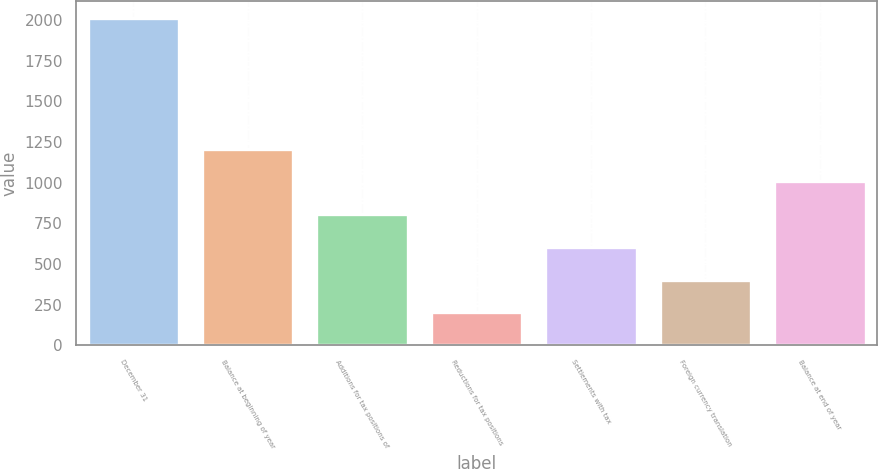Convert chart to OTSL. <chart><loc_0><loc_0><loc_500><loc_500><bar_chart><fcel>December 31<fcel>Balance at beginning of year<fcel>Additions for tax positions of<fcel>Reductions for tax positions<fcel>Settlements with tax<fcel>Foreign currency translation<fcel>Balance at end of year<nl><fcel>2013<fcel>1208.6<fcel>806.4<fcel>203.1<fcel>605.3<fcel>404.2<fcel>1007.5<nl></chart> 